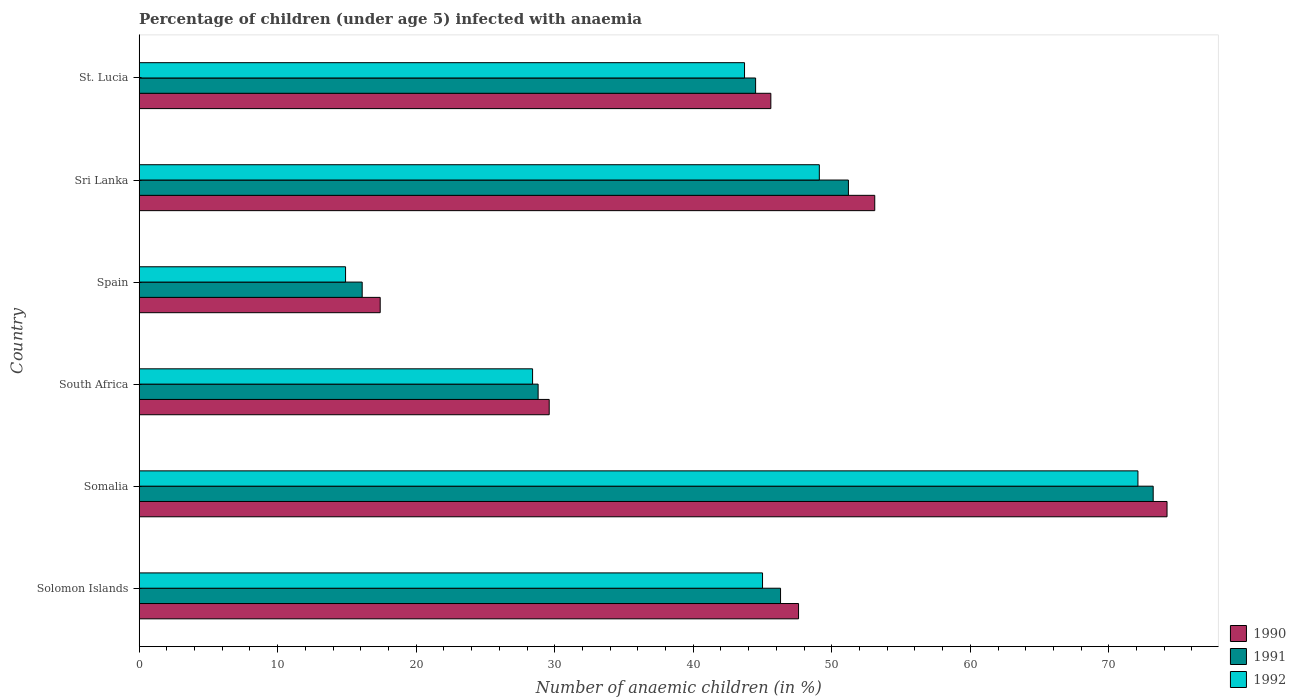How many groups of bars are there?
Your answer should be very brief. 6. Are the number of bars on each tick of the Y-axis equal?
Your response must be concise. Yes. How many bars are there on the 3rd tick from the top?
Ensure brevity in your answer.  3. What is the label of the 4th group of bars from the top?
Your answer should be very brief. South Africa. What is the percentage of children infected with anaemia in in 1991 in South Africa?
Keep it short and to the point. 28.8. Across all countries, what is the maximum percentage of children infected with anaemia in in 1992?
Provide a succinct answer. 72.1. In which country was the percentage of children infected with anaemia in in 1990 maximum?
Give a very brief answer. Somalia. In which country was the percentage of children infected with anaemia in in 1992 minimum?
Ensure brevity in your answer.  Spain. What is the total percentage of children infected with anaemia in in 1990 in the graph?
Offer a terse response. 267.5. What is the difference between the percentage of children infected with anaemia in in 1992 in Solomon Islands and that in Sri Lanka?
Provide a succinct answer. -4.1. What is the difference between the percentage of children infected with anaemia in in 1990 in Spain and the percentage of children infected with anaemia in in 1992 in Somalia?
Provide a short and direct response. -54.7. What is the average percentage of children infected with anaemia in in 1991 per country?
Provide a succinct answer. 43.35. What is the difference between the percentage of children infected with anaemia in in 1992 and percentage of children infected with anaemia in in 1991 in Spain?
Your answer should be compact. -1.2. In how many countries, is the percentage of children infected with anaemia in in 1992 greater than 44 %?
Make the answer very short. 3. What is the ratio of the percentage of children infected with anaemia in in 1992 in South Africa to that in Spain?
Your answer should be compact. 1.91. Is the percentage of children infected with anaemia in in 1992 in Somalia less than that in Sri Lanka?
Your response must be concise. No. What is the difference between the highest and the lowest percentage of children infected with anaemia in in 1992?
Make the answer very short. 57.2. In how many countries, is the percentage of children infected with anaemia in in 1991 greater than the average percentage of children infected with anaemia in in 1991 taken over all countries?
Your answer should be very brief. 4. Is the sum of the percentage of children infected with anaemia in in 1990 in South Africa and Sri Lanka greater than the maximum percentage of children infected with anaemia in in 1992 across all countries?
Give a very brief answer. Yes. What does the 3rd bar from the top in Sri Lanka represents?
Keep it short and to the point. 1990. Is it the case that in every country, the sum of the percentage of children infected with anaemia in in 1992 and percentage of children infected with anaemia in in 1991 is greater than the percentage of children infected with anaemia in in 1990?
Provide a succinct answer. Yes. Are all the bars in the graph horizontal?
Your answer should be compact. Yes. How many countries are there in the graph?
Keep it short and to the point. 6. Does the graph contain any zero values?
Provide a succinct answer. No. Does the graph contain grids?
Offer a very short reply. No. Where does the legend appear in the graph?
Ensure brevity in your answer.  Bottom right. How are the legend labels stacked?
Offer a terse response. Vertical. What is the title of the graph?
Your answer should be very brief. Percentage of children (under age 5) infected with anaemia. What is the label or title of the X-axis?
Give a very brief answer. Number of anaemic children (in %). What is the label or title of the Y-axis?
Your answer should be compact. Country. What is the Number of anaemic children (in %) in 1990 in Solomon Islands?
Ensure brevity in your answer.  47.6. What is the Number of anaemic children (in %) of 1991 in Solomon Islands?
Your answer should be compact. 46.3. What is the Number of anaemic children (in %) in 1992 in Solomon Islands?
Your answer should be very brief. 45. What is the Number of anaemic children (in %) of 1990 in Somalia?
Your response must be concise. 74.2. What is the Number of anaemic children (in %) in 1991 in Somalia?
Provide a short and direct response. 73.2. What is the Number of anaemic children (in %) of 1992 in Somalia?
Your answer should be very brief. 72.1. What is the Number of anaemic children (in %) in 1990 in South Africa?
Offer a very short reply. 29.6. What is the Number of anaemic children (in %) in 1991 in South Africa?
Make the answer very short. 28.8. What is the Number of anaemic children (in %) in 1992 in South Africa?
Keep it short and to the point. 28.4. What is the Number of anaemic children (in %) of 1992 in Spain?
Keep it short and to the point. 14.9. What is the Number of anaemic children (in %) in 1990 in Sri Lanka?
Keep it short and to the point. 53.1. What is the Number of anaemic children (in %) in 1991 in Sri Lanka?
Keep it short and to the point. 51.2. What is the Number of anaemic children (in %) of 1992 in Sri Lanka?
Offer a very short reply. 49.1. What is the Number of anaemic children (in %) in 1990 in St. Lucia?
Ensure brevity in your answer.  45.6. What is the Number of anaemic children (in %) in 1991 in St. Lucia?
Make the answer very short. 44.5. What is the Number of anaemic children (in %) in 1992 in St. Lucia?
Your answer should be very brief. 43.7. Across all countries, what is the maximum Number of anaemic children (in %) of 1990?
Offer a terse response. 74.2. Across all countries, what is the maximum Number of anaemic children (in %) in 1991?
Ensure brevity in your answer.  73.2. Across all countries, what is the maximum Number of anaemic children (in %) in 1992?
Offer a terse response. 72.1. Across all countries, what is the minimum Number of anaemic children (in %) in 1991?
Provide a short and direct response. 16.1. What is the total Number of anaemic children (in %) of 1990 in the graph?
Ensure brevity in your answer.  267.5. What is the total Number of anaemic children (in %) in 1991 in the graph?
Ensure brevity in your answer.  260.1. What is the total Number of anaemic children (in %) in 1992 in the graph?
Offer a very short reply. 253.2. What is the difference between the Number of anaemic children (in %) in 1990 in Solomon Islands and that in Somalia?
Your response must be concise. -26.6. What is the difference between the Number of anaemic children (in %) in 1991 in Solomon Islands and that in Somalia?
Provide a short and direct response. -26.9. What is the difference between the Number of anaemic children (in %) of 1992 in Solomon Islands and that in Somalia?
Your answer should be compact. -27.1. What is the difference between the Number of anaemic children (in %) in 1992 in Solomon Islands and that in South Africa?
Provide a succinct answer. 16.6. What is the difference between the Number of anaemic children (in %) in 1990 in Solomon Islands and that in Spain?
Your response must be concise. 30.2. What is the difference between the Number of anaemic children (in %) of 1991 in Solomon Islands and that in Spain?
Give a very brief answer. 30.2. What is the difference between the Number of anaemic children (in %) of 1992 in Solomon Islands and that in Spain?
Make the answer very short. 30.1. What is the difference between the Number of anaemic children (in %) of 1990 in Solomon Islands and that in Sri Lanka?
Your response must be concise. -5.5. What is the difference between the Number of anaemic children (in %) in 1992 in Solomon Islands and that in Sri Lanka?
Offer a very short reply. -4.1. What is the difference between the Number of anaemic children (in %) in 1990 in Solomon Islands and that in St. Lucia?
Give a very brief answer. 2. What is the difference between the Number of anaemic children (in %) of 1990 in Somalia and that in South Africa?
Provide a succinct answer. 44.6. What is the difference between the Number of anaemic children (in %) in 1991 in Somalia and that in South Africa?
Ensure brevity in your answer.  44.4. What is the difference between the Number of anaemic children (in %) of 1992 in Somalia and that in South Africa?
Your response must be concise. 43.7. What is the difference between the Number of anaemic children (in %) in 1990 in Somalia and that in Spain?
Your answer should be very brief. 56.8. What is the difference between the Number of anaemic children (in %) of 1991 in Somalia and that in Spain?
Offer a very short reply. 57.1. What is the difference between the Number of anaemic children (in %) of 1992 in Somalia and that in Spain?
Provide a succinct answer. 57.2. What is the difference between the Number of anaemic children (in %) in 1990 in Somalia and that in Sri Lanka?
Ensure brevity in your answer.  21.1. What is the difference between the Number of anaemic children (in %) of 1992 in Somalia and that in Sri Lanka?
Offer a terse response. 23. What is the difference between the Number of anaemic children (in %) in 1990 in Somalia and that in St. Lucia?
Offer a very short reply. 28.6. What is the difference between the Number of anaemic children (in %) in 1991 in Somalia and that in St. Lucia?
Your response must be concise. 28.7. What is the difference between the Number of anaemic children (in %) of 1992 in Somalia and that in St. Lucia?
Keep it short and to the point. 28.4. What is the difference between the Number of anaemic children (in %) in 1990 in South Africa and that in Spain?
Provide a short and direct response. 12.2. What is the difference between the Number of anaemic children (in %) of 1990 in South Africa and that in Sri Lanka?
Offer a very short reply. -23.5. What is the difference between the Number of anaemic children (in %) of 1991 in South Africa and that in Sri Lanka?
Provide a short and direct response. -22.4. What is the difference between the Number of anaemic children (in %) in 1992 in South Africa and that in Sri Lanka?
Provide a short and direct response. -20.7. What is the difference between the Number of anaemic children (in %) in 1991 in South Africa and that in St. Lucia?
Keep it short and to the point. -15.7. What is the difference between the Number of anaemic children (in %) in 1992 in South Africa and that in St. Lucia?
Your answer should be compact. -15.3. What is the difference between the Number of anaemic children (in %) of 1990 in Spain and that in Sri Lanka?
Keep it short and to the point. -35.7. What is the difference between the Number of anaemic children (in %) of 1991 in Spain and that in Sri Lanka?
Offer a terse response. -35.1. What is the difference between the Number of anaemic children (in %) of 1992 in Spain and that in Sri Lanka?
Provide a short and direct response. -34.2. What is the difference between the Number of anaemic children (in %) of 1990 in Spain and that in St. Lucia?
Ensure brevity in your answer.  -28.2. What is the difference between the Number of anaemic children (in %) of 1991 in Spain and that in St. Lucia?
Your response must be concise. -28.4. What is the difference between the Number of anaemic children (in %) in 1992 in Spain and that in St. Lucia?
Make the answer very short. -28.8. What is the difference between the Number of anaemic children (in %) of 1990 in Sri Lanka and that in St. Lucia?
Make the answer very short. 7.5. What is the difference between the Number of anaemic children (in %) in 1991 in Sri Lanka and that in St. Lucia?
Give a very brief answer. 6.7. What is the difference between the Number of anaemic children (in %) of 1990 in Solomon Islands and the Number of anaemic children (in %) of 1991 in Somalia?
Offer a terse response. -25.6. What is the difference between the Number of anaemic children (in %) of 1990 in Solomon Islands and the Number of anaemic children (in %) of 1992 in Somalia?
Offer a very short reply. -24.5. What is the difference between the Number of anaemic children (in %) of 1991 in Solomon Islands and the Number of anaemic children (in %) of 1992 in Somalia?
Provide a short and direct response. -25.8. What is the difference between the Number of anaemic children (in %) of 1990 in Solomon Islands and the Number of anaemic children (in %) of 1991 in South Africa?
Your answer should be compact. 18.8. What is the difference between the Number of anaemic children (in %) of 1990 in Solomon Islands and the Number of anaemic children (in %) of 1992 in South Africa?
Your answer should be very brief. 19.2. What is the difference between the Number of anaemic children (in %) in 1990 in Solomon Islands and the Number of anaemic children (in %) in 1991 in Spain?
Your response must be concise. 31.5. What is the difference between the Number of anaemic children (in %) of 1990 in Solomon Islands and the Number of anaemic children (in %) of 1992 in Spain?
Offer a terse response. 32.7. What is the difference between the Number of anaemic children (in %) in 1991 in Solomon Islands and the Number of anaemic children (in %) in 1992 in Spain?
Your answer should be very brief. 31.4. What is the difference between the Number of anaemic children (in %) of 1991 in Solomon Islands and the Number of anaemic children (in %) of 1992 in Sri Lanka?
Your answer should be compact. -2.8. What is the difference between the Number of anaemic children (in %) of 1990 in Solomon Islands and the Number of anaemic children (in %) of 1992 in St. Lucia?
Provide a succinct answer. 3.9. What is the difference between the Number of anaemic children (in %) of 1990 in Somalia and the Number of anaemic children (in %) of 1991 in South Africa?
Provide a short and direct response. 45.4. What is the difference between the Number of anaemic children (in %) in 1990 in Somalia and the Number of anaemic children (in %) in 1992 in South Africa?
Provide a short and direct response. 45.8. What is the difference between the Number of anaemic children (in %) of 1991 in Somalia and the Number of anaemic children (in %) of 1992 in South Africa?
Make the answer very short. 44.8. What is the difference between the Number of anaemic children (in %) in 1990 in Somalia and the Number of anaemic children (in %) in 1991 in Spain?
Your answer should be very brief. 58.1. What is the difference between the Number of anaemic children (in %) of 1990 in Somalia and the Number of anaemic children (in %) of 1992 in Spain?
Your response must be concise. 59.3. What is the difference between the Number of anaemic children (in %) of 1991 in Somalia and the Number of anaemic children (in %) of 1992 in Spain?
Your answer should be compact. 58.3. What is the difference between the Number of anaemic children (in %) in 1990 in Somalia and the Number of anaemic children (in %) in 1992 in Sri Lanka?
Give a very brief answer. 25.1. What is the difference between the Number of anaemic children (in %) in 1991 in Somalia and the Number of anaemic children (in %) in 1992 in Sri Lanka?
Your answer should be very brief. 24.1. What is the difference between the Number of anaemic children (in %) in 1990 in Somalia and the Number of anaemic children (in %) in 1991 in St. Lucia?
Keep it short and to the point. 29.7. What is the difference between the Number of anaemic children (in %) in 1990 in Somalia and the Number of anaemic children (in %) in 1992 in St. Lucia?
Provide a short and direct response. 30.5. What is the difference between the Number of anaemic children (in %) of 1991 in Somalia and the Number of anaemic children (in %) of 1992 in St. Lucia?
Your answer should be compact. 29.5. What is the difference between the Number of anaemic children (in %) in 1990 in South Africa and the Number of anaemic children (in %) in 1991 in Spain?
Your response must be concise. 13.5. What is the difference between the Number of anaemic children (in %) in 1991 in South Africa and the Number of anaemic children (in %) in 1992 in Spain?
Provide a short and direct response. 13.9. What is the difference between the Number of anaemic children (in %) in 1990 in South Africa and the Number of anaemic children (in %) in 1991 in Sri Lanka?
Offer a terse response. -21.6. What is the difference between the Number of anaemic children (in %) in 1990 in South Africa and the Number of anaemic children (in %) in 1992 in Sri Lanka?
Your answer should be compact. -19.5. What is the difference between the Number of anaemic children (in %) of 1991 in South Africa and the Number of anaemic children (in %) of 1992 in Sri Lanka?
Make the answer very short. -20.3. What is the difference between the Number of anaemic children (in %) of 1990 in South Africa and the Number of anaemic children (in %) of 1991 in St. Lucia?
Offer a very short reply. -14.9. What is the difference between the Number of anaemic children (in %) of 1990 in South Africa and the Number of anaemic children (in %) of 1992 in St. Lucia?
Ensure brevity in your answer.  -14.1. What is the difference between the Number of anaemic children (in %) of 1991 in South Africa and the Number of anaemic children (in %) of 1992 in St. Lucia?
Give a very brief answer. -14.9. What is the difference between the Number of anaemic children (in %) of 1990 in Spain and the Number of anaemic children (in %) of 1991 in Sri Lanka?
Offer a very short reply. -33.8. What is the difference between the Number of anaemic children (in %) in 1990 in Spain and the Number of anaemic children (in %) in 1992 in Sri Lanka?
Offer a very short reply. -31.7. What is the difference between the Number of anaemic children (in %) in 1991 in Spain and the Number of anaemic children (in %) in 1992 in Sri Lanka?
Your answer should be compact. -33. What is the difference between the Number of anaemic children (in %) in 1990 in Spain and the Number of anaemic children (in %) in 1991 in St. Lucia?
Offer a terse response. -27.1. What is the difference between the Number of anaemic children (in %) of 1990 in Spain and the Number of anaemic children (in %) of 1992 in St. Lucia?
Make the answer very short. -26.3. What is the difference between the Number of anaemic children (in %) in 1991 in Spain and the Number of anaemic children (in %) in 1992 in St. Lucia?
Give a very brief answer. -27.6. What is the difference between the Number of anaemic children (in %) of 1990 in Sri Lanka and the Number of anaemic children (in %) of 1991 in St. Lucia?
Your response must be concise. 8.6. What is the difference between the Number of anaemic children (in %) in 1990 in Sri Lanka and the Number of anaemic children (in %) in 1992 in St. Lucia?
Offer a very short reply. 9.4. What is the average Number of anaemic children (in %) in 1990 per country?
Make the answer very short. 44.58. What is the average Number of anaemic children (in %) of 1991 per country?
Give a very brief answer. 43.35. What is the average Number of anaemic children (in %) in 1992 per country?
Ensure brevity in your answer.  42.2. What is the difference between the Number of anaemic children (in %) of 1990 and Number of anaemic children (in %) of 1991 in Solomon Islands?
Keep it short and to the point. 1.3. What is the difference between the Number of anaemic children (in %) in 1991 and Number of anaemic children (in %) in 1992 in Solomon Islands?
Your answer should be very brief. 1.3. What is the difference between the Number of anaemic children (in %) in 1990 and Number of anaemic children (in %) in 1991 in Somalia?
Give a very brief answer. 1. What is the difference between the Number of anaemic children (in %) of 1990 and Number of anaemic children (in %) of 1992 in Somalia?
Give a very brief answer. 2.1. What is the difference between the Number of anaemic children (in %) in 1991 and Number of anaemic children (in %) in 1992 in Somalia?
Ensure brevity in your answer.  1.1. What is the difference between the Number of anaemic children (in %) in 1990 and Number of anaemic children (in %) in 1991 in South Africa?
Ensure brevity in your answer.  0.8. What is the difference between the Number of anaemic children (in %) in 1990 and Number of anaemic children (in %) in 1992 in South Africa?
Your answer should be very brief. 1.2. What is the difference between the Number of anaemic children (in %) of 1991 and Number of anaemic children (in %) of 1992 in South Africa?
Provide a succinct answer. 0.4. What is the difference between the Number of anaemic children (in %) of 1990 and Number of anaemic children (in %) of 1991 in Spain?
Your answer should be very brief. 1.3. What is the difference between the Number of anaemic children (in %) in 1990 and Number of anaemic children (in %) in 1992 in Spain?
Your response must be concise. 2.5. What is the difference between the Number of anaemic children (in %) in 1990 and Number of anaemic children (in %) in 1992 in Sri Lanka?
Offer a very short reply. 4. What is the difference between the Number of anaemic children (in %) in 1991 and Number of anaemic children (in %) in 1992 in Sri Lanka?
Ensure brevity in your answer.  2.1. What is the difference between the Number of anaemic children (in %) in 1990 and Number of anaemic children (in %) in 1992 in St. Lucia?
Your answer should be compact. 1.9. What is the difference between the Number of anaemic children (in %) in 1991 and Number of anaemic children (in %) in 1992 in St. Lucia?
Give a very brief answer. 0.8. What is the ratio of the Number of anaemic children (in %) in 1990 in Solomon Islands to that in Somalia?
Keep it short and to the point. 0.64. What is the ratio of the Number of anaemic children (in %) of 1991 in Solomon Islands to that in Somalia?
Your answer should be very brief. 0.63. What is the ratio of the Number of anaemic children (in %) in 1992 in Solomon Islands to that in Somalia?
Ensure brevity in your answer.  0.62. What is the ratio of the Number of anaemic children (in %) of 1990 in Solomon Islands to that in South Africa?
Your answer should be compact. 1.61. What is the ratio of the Number of anaemic children (in %) in 1991 in Solomon Islands to that in South Africa?
Make the answer very short. 1.61. What is the ratio of the Number of anaemic children (in %) in 1992 in Solomon Islands to that in South Africa?
Give a very brief answer. 1.58. What is the ratio of the Number of anaemic children (in %) of 1990 in Solomon Islands to that in Spain?
Your answer should be compact. 2.74. What is the ratio of the Number of anaemic children (in %) in 1991 in Solomon Islands to that in Spain?
Keep it short and to the point. 2.88. What is the ratio of the Number of anaemic children (in %) in 1992 in Solomon Islands to that in Spain?
Your answer should be very brief. 3.02. What is the ratio of the Number of anaemic children (in %) in 1990 in Solomon Islands to that in Sri Lanka?
Give a very brief answer. 0.9. What is the ratio of the Number of anaemic children (in %) of 1991 in Solomon Islands to that in Sri Lanka?
Give a very brief answer. 0.9. What is the ratio of the Number of anaemic children (in %) of 1992 in Solomon Islands to that in Sri Lanka?
Offer a terse response. 0.92. What is the ratio of the Number of anaemic children (in %) in 1990 in Solomon Islands to that in St. Lucia?
Offer a terse response. 1.04. What is the ratio of the Number of anaemic children (in %) of 1991 in Solomon Islands to that in St. Lucia?
Your response must be concise. 1.04. What is the ratio of the Number of anaemic children (in %) in 1992 in Solomon Islands to that in St. Lucia?
Offer a very short reply. 1.03. What is the ratio of the Number of anaemic children (in %) in 1990 in Somalia to that in South Africa?
Keep it short and to the point. 2.51. What is the ratio of the Number of anaemic children (in %) in 1991 in Somalia to that in South Africa?
Give a very brief answer. 2.54. What is the ratio of the Number of anaemic children (in %) of 1992 in Somalia to that in South Africa?
Your response must be concise. 2.54. What is the ratio of the Number of anaemic children (in %) in 1990 in Somalia to that in Spain?
Ensure brevity in your answer.  4.26. What is the ratio of the Number of anaemic children (in %) of 1991 in Somalia to that in Spain?
Your answer should be very brief. 4.55. What is the ratio of the Number of anaemic children (in %) in 1992 in Somalia to that in Spain?
Provide a succinct answer. 4.84. What is the ratio of the Number of anaemic children (in %) in 1990 in Somalia to that in Sri Lanka?
Make the answer very short. 1.4. What is the ratio of the Number of anaemic children (in %) in 1991 in Somalia to that in Sri Lanka?
Your answer should be compact. 1.43. What is the ratio of the Number of anaemic children (in %) in 1992 in Somalia to that in Sri Lanka?
Keep it short and to the point. 1.47. What is the ratio of the Number of anaemic children (in %) of 1990 in Somalia to that in St. Lucia?
Your answer should be very brief. 1.63. What is the ratio of the Number of anaemic children (in %) of 1991 in Somalia to that in St. Lucia?
Provide a succinct answer. 1.64. What is the ratio of the Number of anaemic children (in %) of 1992 in Somalia to that in St. Lucia?
Provide a short and direct response. 1.65. What is the ratio of the Number of anaemic children (in %) of 1990 in South Africa to that in Spain?
Your answer should be very brief. 1.7. What is the ratio of the Number of anaemic children (in %) in 1991 in South Africa to that in Spain?
Give a very brief answer. 1.79. What is the ratio of the Number of anaemic children (in %) in 1992 in South Africa to that in Spain?
Your response must be concise. 1.91. What is the ratio of the Number of anaemic children (in %) of 1990 in South Africa to that in Sri Lanka?
Give a very brief answer. 0.56. What is the ratio of the Number of anaemic children (in %) of 1991 in South Africa to that in Sri Lanka?
Ensure brevity in your answer.  0.56. What is the ratio of the Number of anaemic children (in %) in 1992 in South Africa to that in Sri Lanka?
Provide a short and direct response. 0.58. What is the ratio of the Number of anaemic children (in %) in 1990 in South Africa to that in St. Lucia?
Ensure brevity in your answer.  0.65. What is the ratio of the Number of anaemic children (in %) of 1991 in South Africa to that in St. Lucia?
Keep it short and to the point. 0.65. What is the ratio of the Number of anaemic children (in %) of 1992 in South Africa to that in St. Lucia?
Your answer should be compact. 0.65. What is the ratio of the Number of anaemic children (in %) of 1990 in Spain to that in Sri Lanka?
Provide a short and direct response. 0.33. What is the ratio of the Number of anaemic children (in %) in 1991 in Spain to that in Sri Lanka?
Your answer should be very brief. 0.31. What is the ratio of the Number of anaemic children (in %) of 1992 in Spain to that in Sri Lanka?
Provide a succinct answer. 0.3. What is the ratio of the Number of anaemic children (in %) in 1990 in Spain to that in St. Lucia?
Give a very brief answer. 0.38. What is the ratio of the Number of anaemic children (in %) in 1991 in Spain to that in St. Lucia?
Provide a succinct answer. 0.36. What is the ratio of the Number of anaemic children (in %) of 1992 in Spain to that in St. Lucia?
Your response must be concise. 0.34. What is the ratio of the Number of anaemic children (in %) of 1990 in Sri Lanka to that in St. Lucia?
Offer a terse response. 1.16. What is the ratio of the Number of anaemic children (in %) of 1991 in Sri Lanka to that in St. Lucia?
Give a very brief answer. 1.15. What is the ratio of the Number of anaemic children (in %) in 1992 in Sri Lanka to that in St. Lucia?
Ensure brevity in your answer.  1.12. What is the difference between the highest and the second highest Number of anaemic children (in %) in 1990?
Your response must be concise. 21.1. What is the difference between the highest and the second highest Number of anaemic children (in %) in 1992?
Offer a very short reply. 23. What is the difference between the highest and the lowest Number of anaemic children (in %) in 1990?
Your answer should be very brief. 56.8. What is the difference between the highest and the lowest Number of anaemic children (in %) in 1991?
Your answer should be very brief. 57.1. What is the difference between the highest and the lowest Number of anaemic children (in %) in 1992?
Provide a short and direct response. 57.2. 